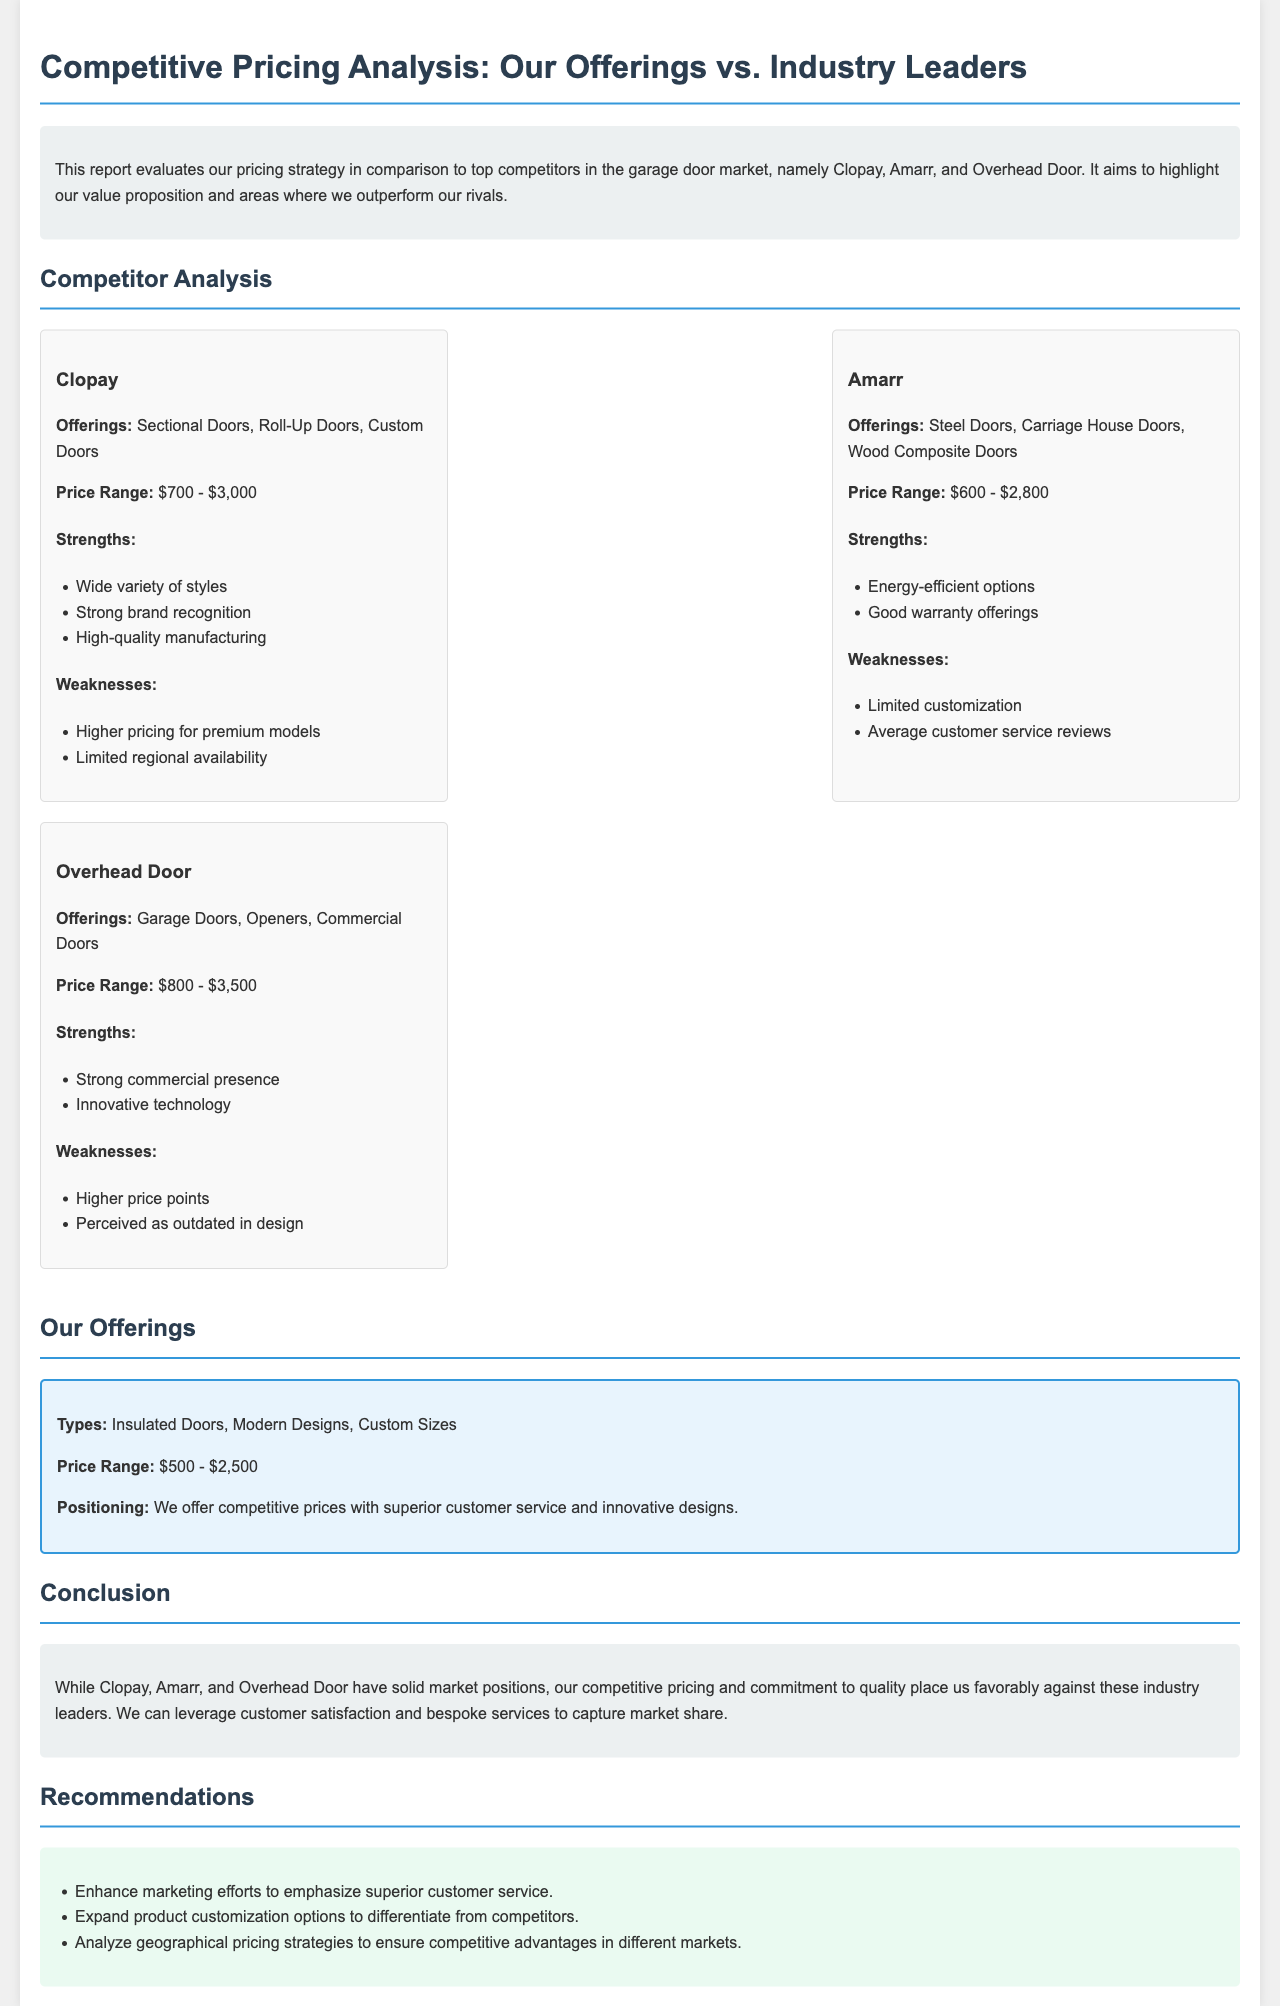What is the price range for Clopay? The document states that Clopay's price range is between $700 and $3,000.
Answer: $700 - $3,000 What types of doors does Amarr offer? The report mentions that Amarr offers Steel Doors, Carriage House Doors, and Wood Composite Doors.
Answer: Steel Doors, Carriage House Doors, Wood Composite Doors What is the strength of Overhead Door mentioned in the report? According to the analysis, a strength of Overhead Door is its strong commercial presence.
Answer: Strong commercial presence What is our price range compared to competitors? The document reveals that our price range is $500 - $2,500, which is lower than some competitors.
Answer: $500 - $2,500 What do the recommendations suggest regarding customer service? The recommendations advise enhancing marketing efforts to emphasize superior customer service.
Answer: Superior customer service What is a weakness of Clopay according to the report? The document identifies that Clopay has higher pricing for premium models as a weakness.
Answer: Higher pricing for premium models What is positioned as our key differentiator in the market? The report highlights competitive prices with superior customer service as our key differentiator.
Answer: Superior customer service Which competitor has innovative technology as a strength? The analysis states that Overhead Door has innovative technology as one of its strengths.
Answer: Overhead Door What is the stated conclusion about our market position? The conclusion in the document emphasizes that our competitive pricing and commitment to quality place us favorably against competitors.
Answer: Favorably against competitors 